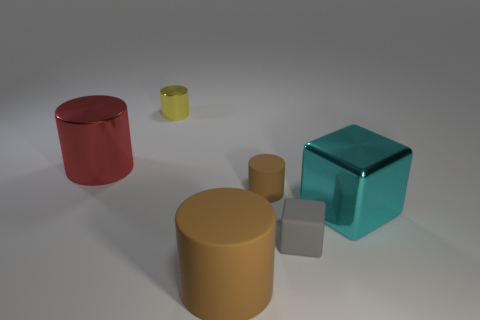There is a big brown object in front of the small yellow object; does it have the same shape as the tiny matte object that is behind the gray rubber object?
Make the answer very short. Yes. There is a matte object that is the same size as the cyan shiny cube; what is its shape?
Your answer should be compact. Cylinder. Are there the same number of cylinders that are to the right of the large brown object and small shiny cylinders that are left of the metal block?
Offer a terse response. Yes. Is there any other thing that is the same shape as the large brown thing?
Your answer should be very brief. Yes. Do the brown thing behind the cyan metallic object and the gray object have the same material?
Give a very brief answer. Yes. There is a cube that is the same size as the yellow cylinder; what is it made of?
Provide a succinct answer. Rubber. What number of other objects are the same material as the gray object?
Ensure brevity in your answer.  2. Is the size of the cyan metal cube the same as the brown cylinder that is in front of the small brown cylinder?
Offer a terse response. Yes. Is the number of tiny gray rubber cubes on the left side of the small gray rubber cube less than the number of things that are on the left side of the tiny brown cylinder?
Offer a terse response. Yes. How big is the cylinder in front of the small gray rubber object?
Your answer should be compact. Large. 